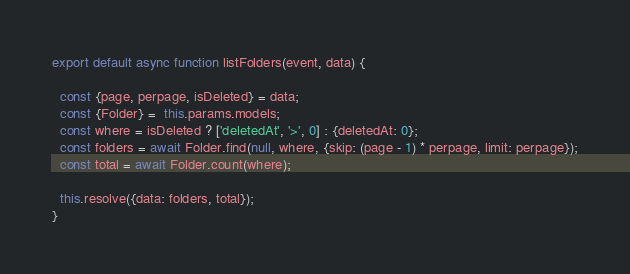<code> <loc_0><loc_0><loc_500><loc_500><_JavaScript_>export default async function listFolders(event, data) {

  const {page, perpage, isDeleted} = data;
  const {Folder} =  this.params.models;
  const where = isDeleted ? ['deletedAt', '>', 0] : {deletedAt: 0};
  const folders = await Folder.find(null, where, {skip: (page - 1) * perpage, limit: perpage});
  const total = await Folder.count(where);

  this.resolve({data: folders, total});
}
</code> 